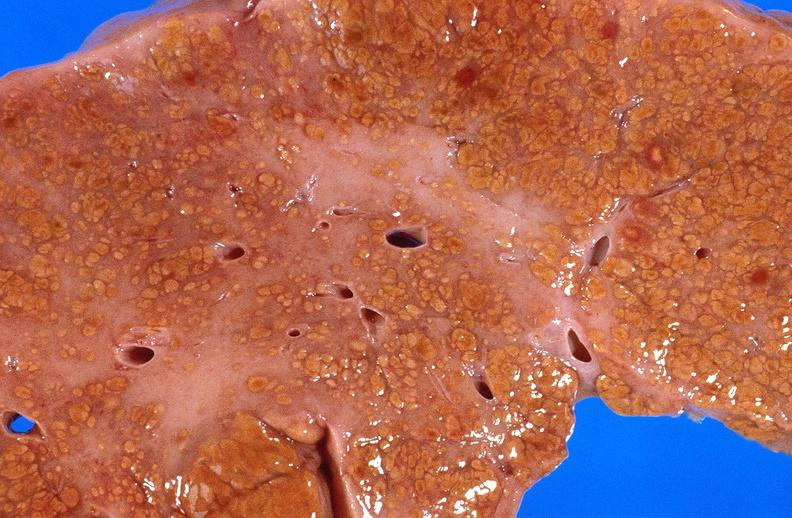does this image show cirrhosis?
Answer the question using a single word or phrase. Yes 